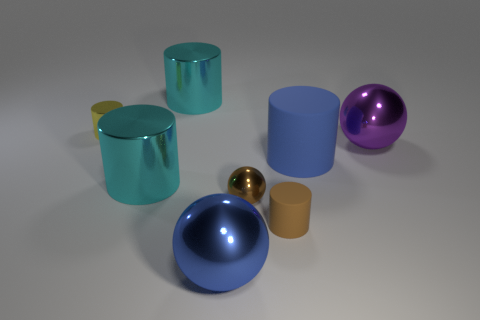What is the color of the shiny cylinder that is in front of the big purple thing to the right of the blue object to the left of the tiny brown matte cylinder?
Keep it short and to the point. Cyan. Does the brown ball have the same material as the big purple thing?
Keep it short and to the point. Yes. Are there any cyan things that have the same size as the blue metal ball?
Give a very brief answer. Yes. There is a yellow object that is the same size as the brown metal thing; what is it made of?
Give a very brief answer. Metal. Are there any other objects of the same shape as the small brown rubber thing?
Provide a short and direct response. Yes. There is a object that is the same color as the large matte cylinder; what is it made of?
Keep it short and to the point. Metal. What is the shape of the cyan shiny thing that is behind the small yellow metal cylinder?
Your answer should be compact. Cylinder. How many large blue objects are there?
Provide a succinct answer. 2. What color is the object that is made of the same material as the brown cylinder?
Give a very brief answer. Blue. What number of small things are either cylinders or yellow cylinders?
Your answer should be compact. 2. 